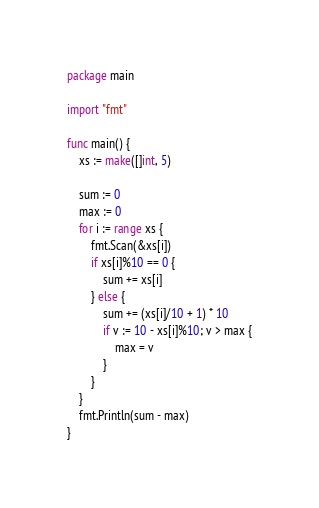Convert code to text. <code><loc_0><loc_0><loc_500><loc_500><_Go_>package main

import "fmt"

func main() {
	xs := make([]int, 5)

	sum := 0
	max := 0
	for i := range xs {
		fmt.Scan(&xs[i])
		if xs[i]%10 == 0 {
			sum += xs[i]
		} else {
			sum += (xs[i]/10 + 1) * 10
			if v := 10 - xs[i]%10; v > max {
				max = v
			}
		}
	}
	fmt.Println(sum - max)
}
</code> 